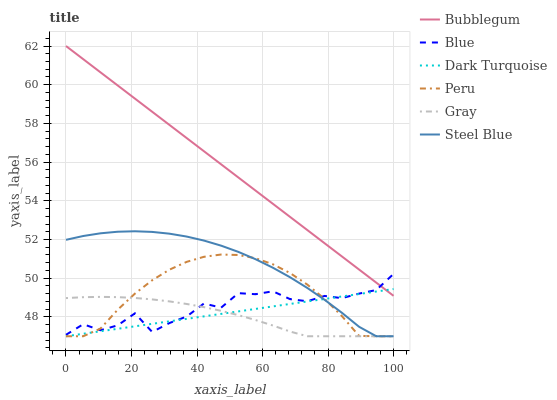Does Gray have the minimum area under the curve?
Answer yes or no. Yes. Does Bubblegum have the maximum area under the curve?
Answer yes or no. Yes. Does Dark Turquoise have the minimum area under the curve?
Answer yes or no. No. Does Dark Turquoise have the maximum area under the curve?
Answer yes or no. No. Is Bubblegum the smoothest?
Answer yes or no. Yes. Is Blue the roughest?
Answer yes or no. Yes. Is Gray the smoothest?
Answer yes or no. No. Is Gray the roughest?
Answer yes or no. No. Does Gray have the lowest value?
Answer yes or no. Yes. Does Bubblegum have the lowest value?
Answer yes or no. No. Does Bubblegum have the highest value?
Answer yes or no. Yes. Does Dark Turquoise have the highest value?
Answer yes or no. No. Is Peru less than Bubblegum?
Answer yes or no. Yes. Is Bubblegum greater than Steel Blue?
Answer yes or no. Yes. Does Gray intersect Peru?
Answer yes or no. Yes. Is Gray less than Peru?
Answer yes or no. No. Is Gray greater than Peru?
Answer yes or no. No. Does Peru intersect Bubblegum?
Answer yes or no. No. 